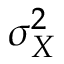Convert formula to latex. <formula><loc_0><loc_0><loc_500><loc_500>\sigma _ { X } ^ { 2 }</formula> 